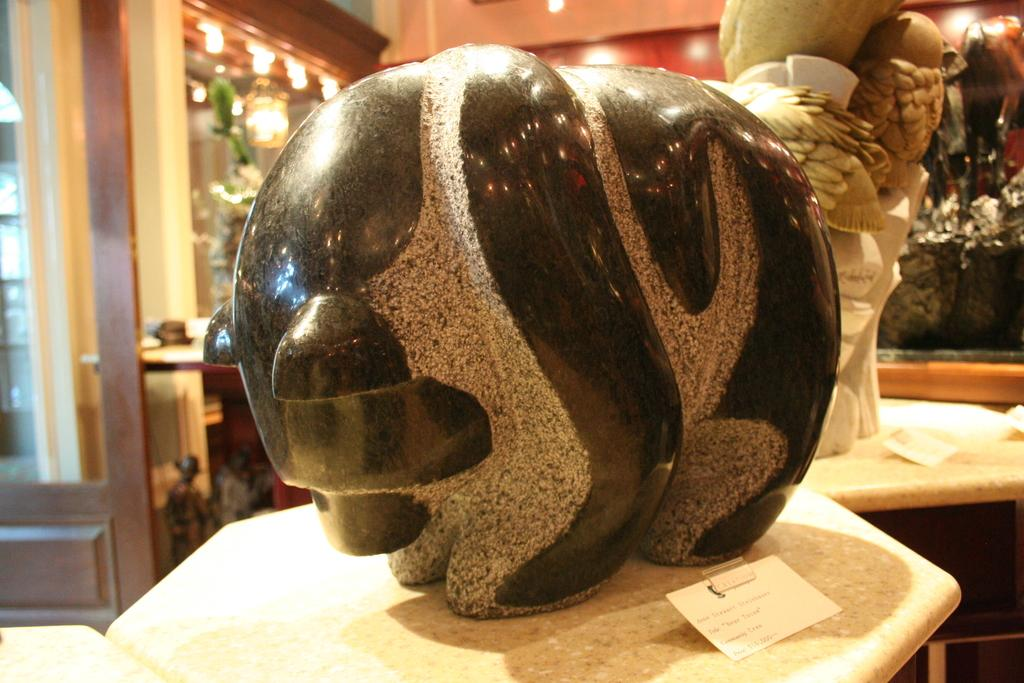What can be seen on the tables in the image? There are objects placed on tables in the image. What can be seen in the background of the image? There are lights visible in the background of the image. What type of note is being discussed in the image? There is no note being discussed in the image; it only shows objects on tables and lights in the background. 